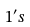<formula> <loc_0><loc_0><loc_500><loc_500>1 ^ { \prime } s</formula> 